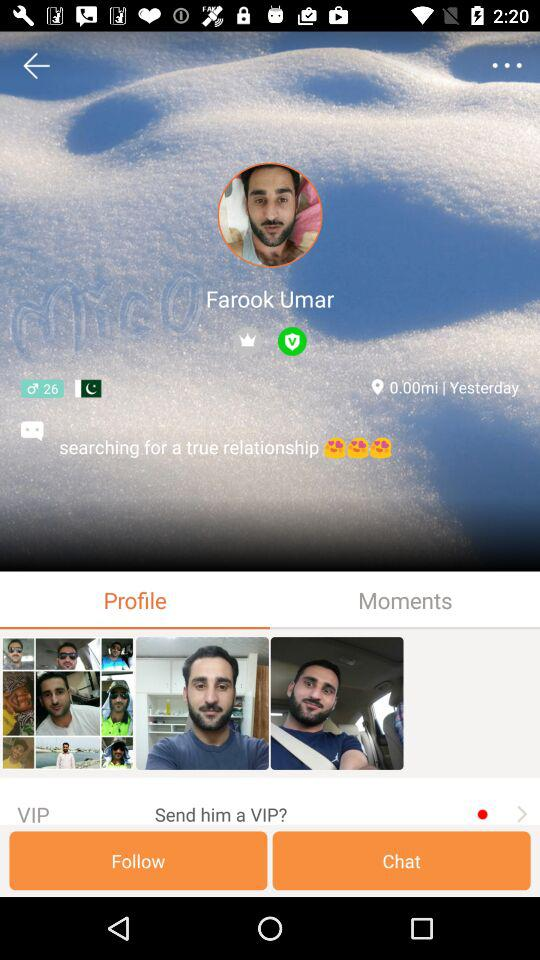Which country is Farook from? Farook is from Pakistan. 